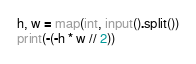Convert code to text. <code><loc_0><loc_0><loc_500><loc_500><_Python_>
h, w = map(int, input().split())
print(-(-h * w // 2))</code> 